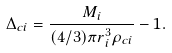<formula> <loc_0><loc_0><loc_500><loc_500>\Delta _ { c i } = \frac { M _ { i } } { ( 4 / 3 ) \pi r _ { i } ^ { 3 } \rho _ { c i } } - 1 .</formula> 